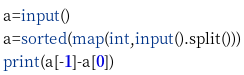Convert code to text. <code><loc_0><loc_0><loc_500><loc_500><_Python_>a=input()
a=sorted(map(int,input().split()))
print(a[-1]-a[0])

</code> 